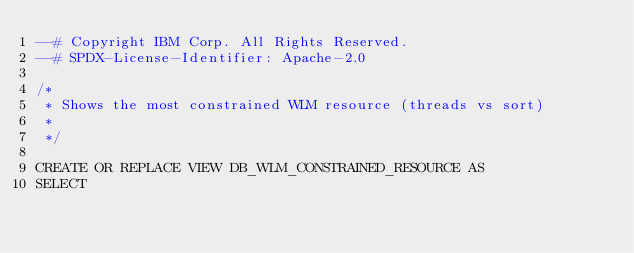<code> <loc_0><loc_0><loc_500><loc_500><_SQL_>--# Copyright IBM Corp. All Rights Reserved.
--# SPDX-License-Identifier: Apache-2.0

/*
 * Shows the most constrained WLM resource (threads vs sort)
 * 
 */

CREATE OR REPLACE VIEW DB_WLM_CONSTRAINED_RESOURCE AS
SELECT</code> 